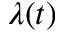<formula> <loc_0><loc_0><loc_500><loc_500>\lambda ( t )</formula> 